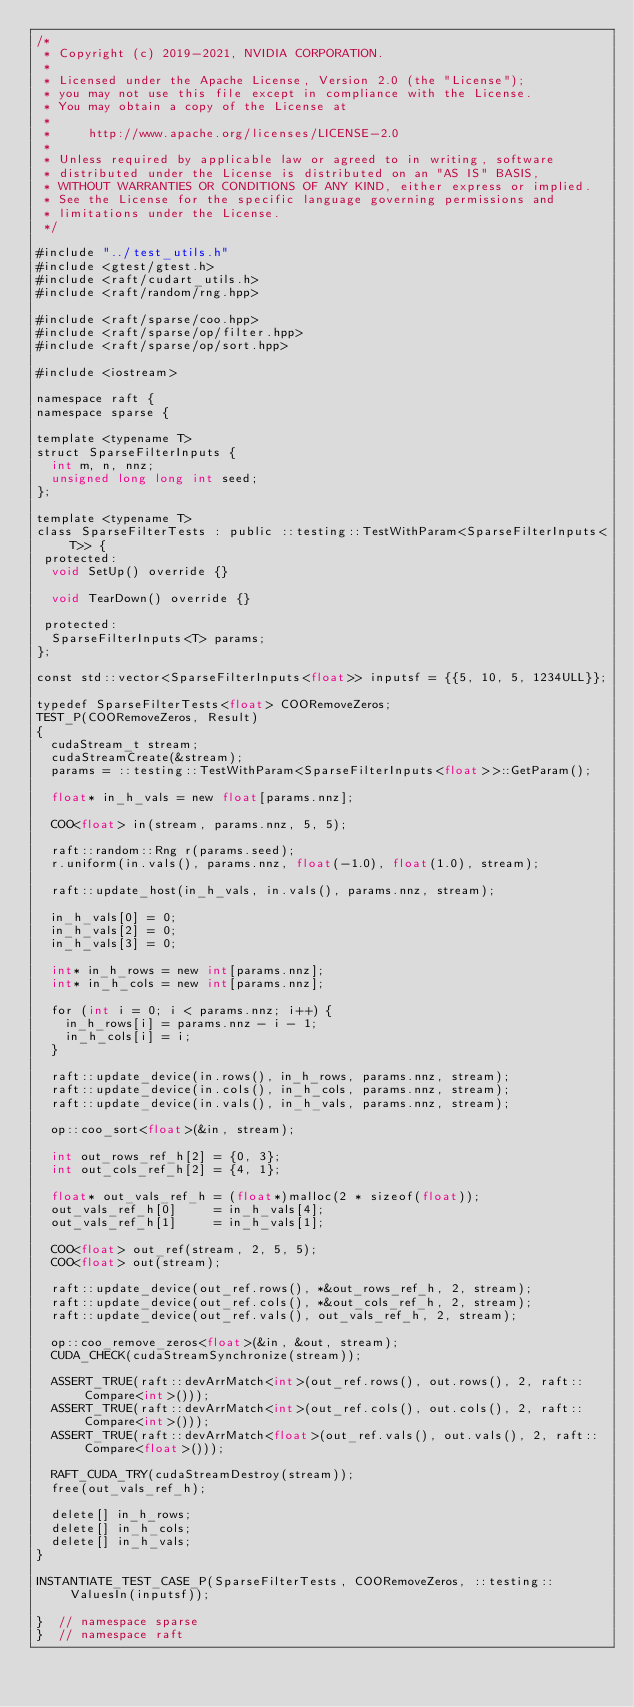<code> <loc_0><loc_0><loc_500><loc_500><_Cuda_>/*
 * Copyright (c) 2019-2021, NVIDIA CORPORATION.
 *
 * Licensed under the Apache License, Version 2.0 (the "License");
 * you may not use this file except in compliance with the License.
 * You may obtain a copy of the License at
 *
 *     http://www.apache.org/licenses/LICENSE-2.0
 *
 * Unless required by applicable law or agreed to in writing, software
 * distributed under the License is distributed on an "AS IS" BASIS,
 * WITHOUT WARRANTIES OR CONDITIONS OF ANY KIND, either express or implied.
 * See the License for the specific language governing permissions and
 * limitations under the License.
 */

#include "../test_utils.h"
#include <gtest/gtest.h>
#include <raft/cudart_utils.h>
#include <raft/random/rng.hpp>

#include <raft/sparse/coo.hpp>
#include <raft/sparse/op/filter.hpp>
#include <raft/sparse/op/sort.hpp>

#include <iostream>

namespace raft {
namespace sparse {

template <typename T>
struct SparseFilterInputs {
  int m, n, nnz;
  unsigned long long int seed;
};

template <typename T>
class SparseFilterTests : public ::testing::TestWithParam<SparseFilterInputs<T>> {
 protected:
  void SetUp() override {}

  void TearDown() override {}

 protected:
  SparseFilterInputs<T> params;
};

const std::vector<SparseFilterInputs<float>> inputsf = {{5, 10, 5, 1234ULL}};

typedef SparseFilterTests<float> COORemoveZeros;
TEST_P(COORemoveZeros, Result)
{
  cudaStream_t stream;
  cudaStreamCreate(&stream);
  params = ::testing::TestWithParam<SparseFilterInputs<float>>::GetParam();

  float* in_h_vals = new float[params.nnz];

  COO<float> in(stream, params.nnz, 5, 5);

  raft::random::Rng r(params.seed);
  r.uniform(in.vals(), params.nnz, float(-1.0), float(1.0), stream);

  raft::update_host(in_h_vals, in.vals(), params.nnz, stream);

  in_h_vals[0] = 0;
  in_h_vals[2] = 0;
  in_h_vals[3] = 0;

  int* in_h_rows = new int[params.nnz];
  int* in_h_cols = new int[params.nnz];

  for (int i = 0; i < params.nnz; i++) {
    in_h_rows[i] = params.nnz - i - 1;
    in_h_cols[i] = i;
  }

  raft::update_device(in.rows(), in_h_rows, params.nnz, stream);
  raft::update_device(in.cols(), in_h_cols, params.nnz, stream);
  raft::update_device(in.vals(), in_h_vals, params.nnz, stream);

  op::coo_sort<float>(&in, stream);

  int out_rows_ref_h[2] = {0, 3};
  int out_cols_ref_h[2] = {4, 1};

  float* out_vals_ref_h = (float*)malloc(2 * sizeof(float));
  out_vals_ref_h[0]     = in_h_vals[4];
  out_vals_ref_h[1]     = in_h_vals[1];

  COO<float> out_ref(stream, 2, 5, 5);
  COO<float> out(stream);

  raft::update_device(out_ref.rows(), *&out_rows_ref_h, 2, stream);
  raft::update_device(out_ref.cols(), *&out_cols_ref_h, 2, stream);
  raft::update_device(out_ref.vals(), out_vals_ref_h, 2, stream);

  op::coo_remove_zeros<float>(&in, &out, stream);
  CUDA_CHECK(cudaStreamSynchronize(stream));

  ASSERT_TRUE(raft::devArrMatch<int>(out_ref.rows(), out.rows(), 2, raft::Compare<int>()));
  ASSERT_TRUE(raft::devArrMatch<int>(out_ref.cols(), out.cols(), 2, raft::Compare<int>()));
  ASSERT_TRUE(raft::devArrMatch<float>(out_ref.vals(), out.vals(), 2, raft::Compare<float>()));

  RAFT_CUDA_TRY(cudaStreamDestroy(stream));
  free(out_vals_ref_h);

  delete[] in_h_rows;
  delete[] in_h_cols;
  delete[] in_h_vals;
}

INSTANTIATE_TEST_CASE_P(SparseFilterTests, COORemoveZeros, ::testing::ValuesIn(inputsf));

}  // namespace sparse
}  // namespace raft
</code> 